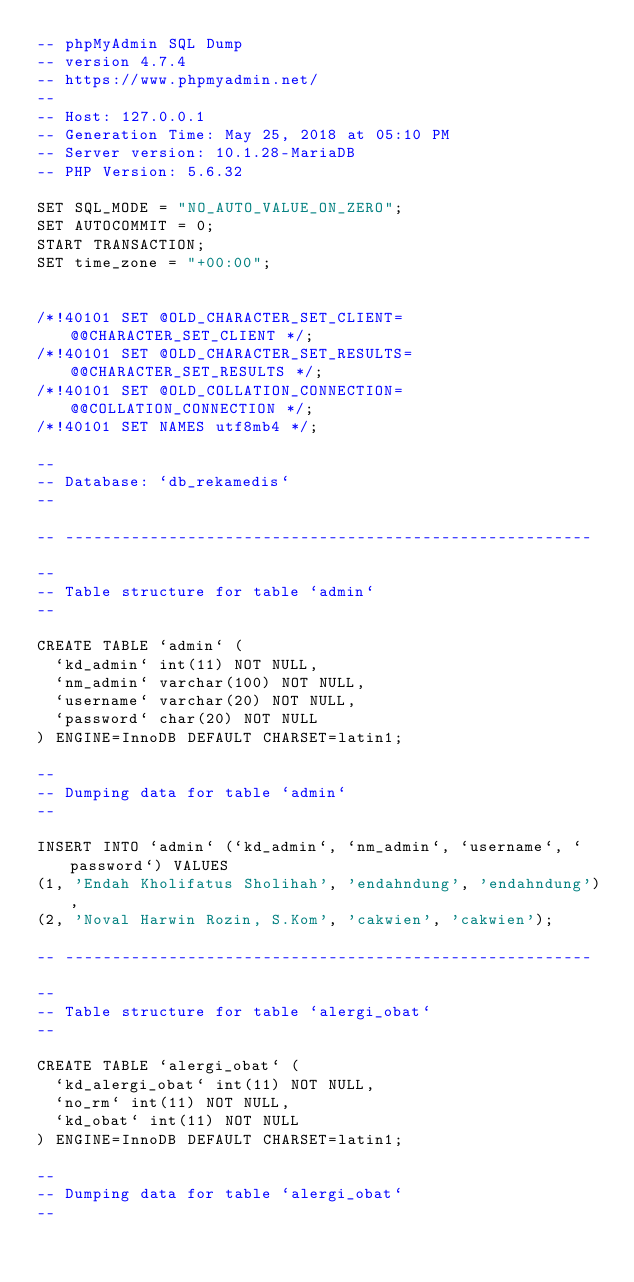Convert code to text. <code><loc_0><loc_0><loc_500><loc_500><_SQL_>-- phpMyAdmin SQL Dump
-- version 4.7.4
-- https://www.phpmyadmin.net/
--
-- Host: 127.0.0.1
-- Generation Time: May 25, 2018 at 05:10 PM
-- Server version: 10.1.28-MariaDB
-- PHP Version: 5.6.32

SET SQL_MODE = "NO_AUTO_VALUE_ON_ZERO";
SET AUTOCOMMIT = 0;
START TRANSACTION;
SET time_zone = "+00:00";


/*!40101 SET @OLD_CHARACTER_SET_CLIENT=@@CHARACTER_SET_CLIENT */;
/*!40101 SET @OLD_CHARACTER_SET_RESULTS=@@CHARACTER_SET_RESULTS */;
/*!40101 SET @OLD_COLLATION_CONNECTION=@@COLLATION_CONNECTION */;
/*!40101 SET NAMES utf8mb4 */;

--
-- Database: `db_rekamedis`
--

-- --------------------------------------------------------

--
-- Table structure for table `admin`
--

CREATE TABLE `admin` (
  `kd_admin` int(11) NOT NULL,
  `nm_admin` varchar(100) NOT NULL,
  `username` varchar(20) NOT NULL,
  `password` char(20) NOT NULL
) ENGINE=InnoDB DEFAULT CHARSET=latin1;

--
-- Dumping data for table `admin`
--

INSERT INTO `admin` (`kd_admin`, `nm_admin`, `username`, `password`) VALUES
(1, 'Endah Kholifatus Sholihah', 'endahndung', 'endahndung'),
(2, 'Noval Harwin Rozin, S.Kom', 'cakwien', 'cakwien');

-- --------------------------------------------------------

--
-- Table structure for table `alergi_obat`
--

CREATE TABLE `alergi_obat` (
  `kd_alergi_obat` int(11) NOT NULL,
  `no_rm` int(11) NOT NULL,
  `kd_obat` int(11) NOT NULL
) ENGINE=InnoDB DEFAULT CHARSET=latin1;

--
-- Dumping data for table `alergi_obat`
--
</code> 